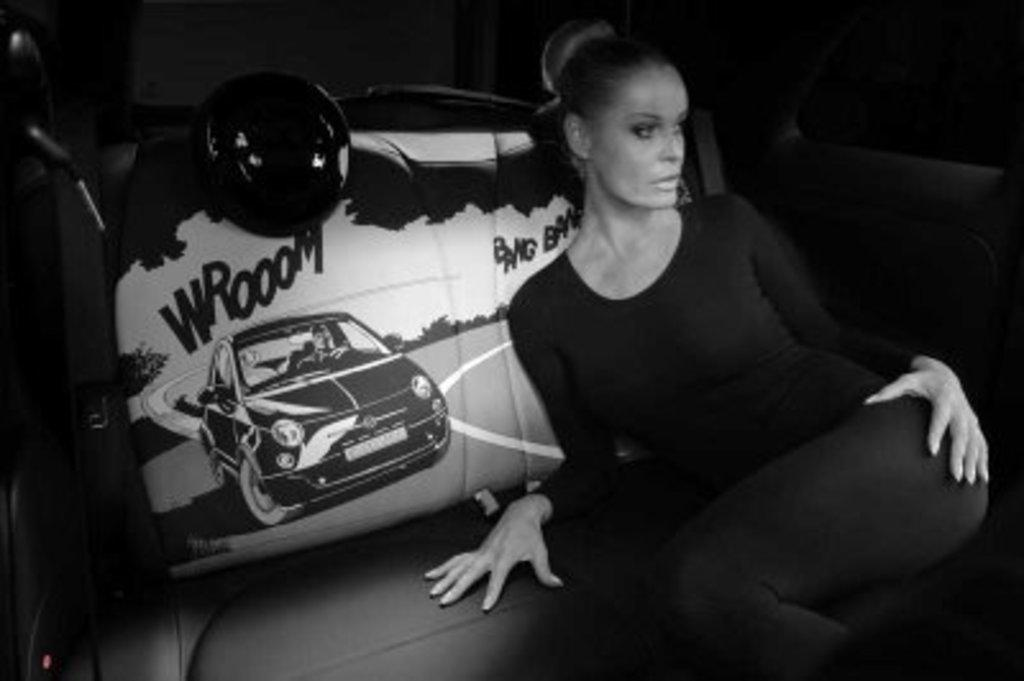Who is present in the image? There is a woman in the image. What is the woman doing in the image? The woman is sitting in a car. What type of road can be seen in the image? There is no road visible in the image; it only shows a woman sitting in a car. How does the woman's breath appear in the image? The image does not show the woman's breath, so it cannot be determined from the image. 